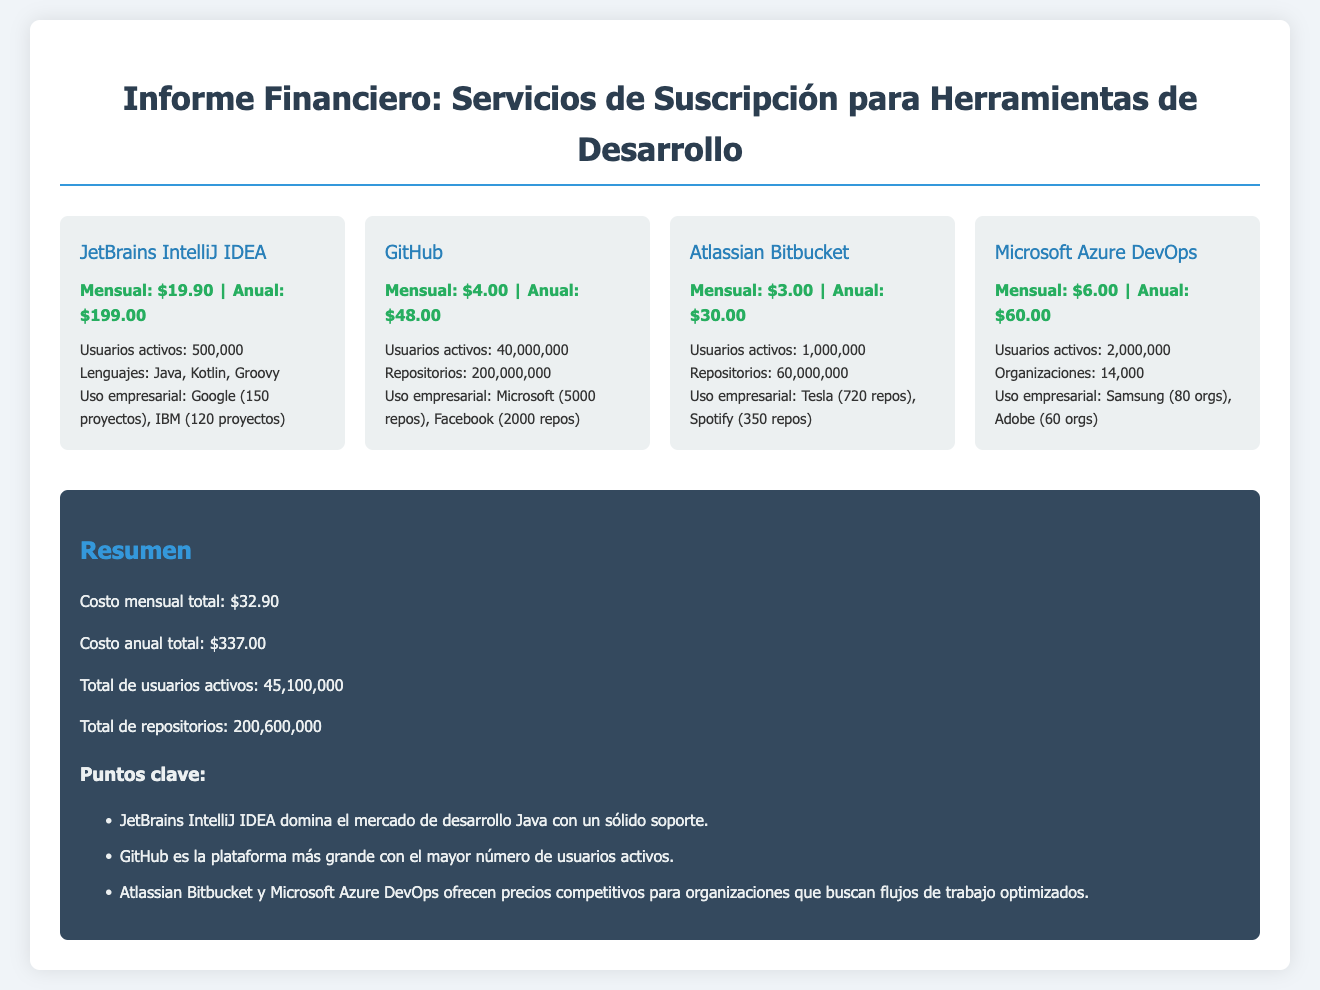¿Cuál es el costo mensual de JetBrains IntelliJ IDEA? El costo mensual de JetBrains IntelliJ IDEA se encuentra en la sección del servicio y es de $19.90.
Answer: $19.90 ¿Cuántos usuarios activos tiene GitHub? La cantidad de usuarios activos de GitHub está listada en la información del servicio como 40,000,000.
Answer: 40,000,000 ¿Cuál es el costo anual total? El costo anual total se resume al final del documento y es de $337.00.
Answer: $337.00 ¿Qué empresa utiliza Microsoft Azure DevOps? La sección de uso empresarial indica que Samsung utiliza Microsoft Azure DevOps.
Answer: Samsung ¿Cuál es el total de repositorios combinados? El total de repositorios se calcula sumando los repositorios informados de todos los servicios, resultando en 200,600,000.
Answer: 200,600,000 ¿Cuántos lenguajes soporta JetBrains IntelliJ IDEA? La información del servicio señala que JetBrains IntelliJ IDEA soporta Java, Kotlin y Groovy.
Answer: Java, Kotlin, Groovy ¿Qué servicio tiene el mayor número de usuarios activos? Al revisar la sección de usuarios activos, GitHub tiene el mayor número con 40,000,000 de usuarios.
Answer: GitHub ¿Cuál es el costo mensual total de todos los servicios? El documento presenta el costo mensual total al final como $32.90.
Answer: $32.90 